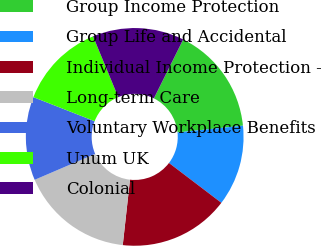Convert chart. <chart><loc_0><loc_0><loc_500><loc_500><pie_chart><fcel>Group Income Protection<fcel>Group Life and Accidental<fcel>Individual Income Protection -<fcel>Long-term Care<fcel>Voluntary Workplace Benefits<fcel>Unum UK<fcel>Colonial<nl><fcel>16.0%<fcel>12.0%<fcel>16.4%<fcel>16.8%<fcel>12.4%<fcel>12.8%<fcel>13.6%<nl></chart> 